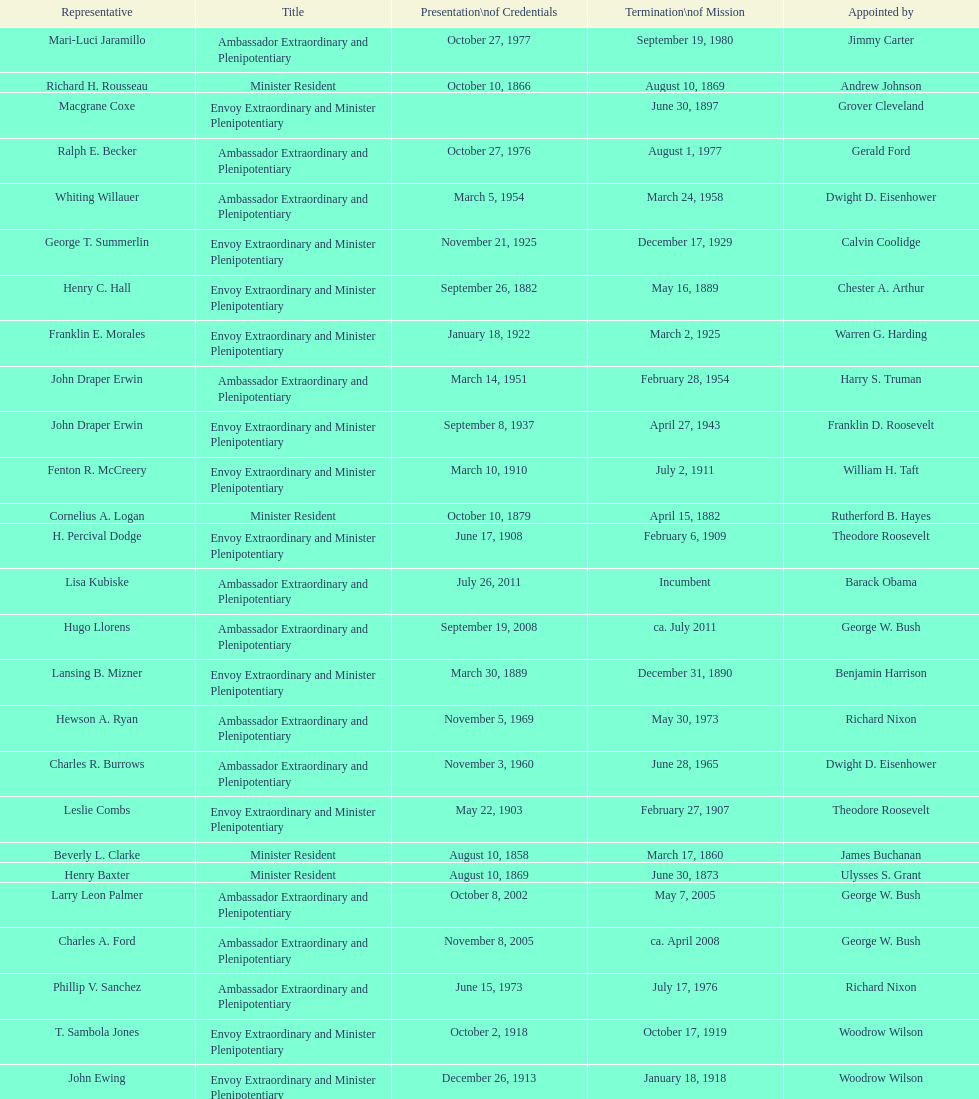Which date is below april 17, 1854 March 17, 1860. 